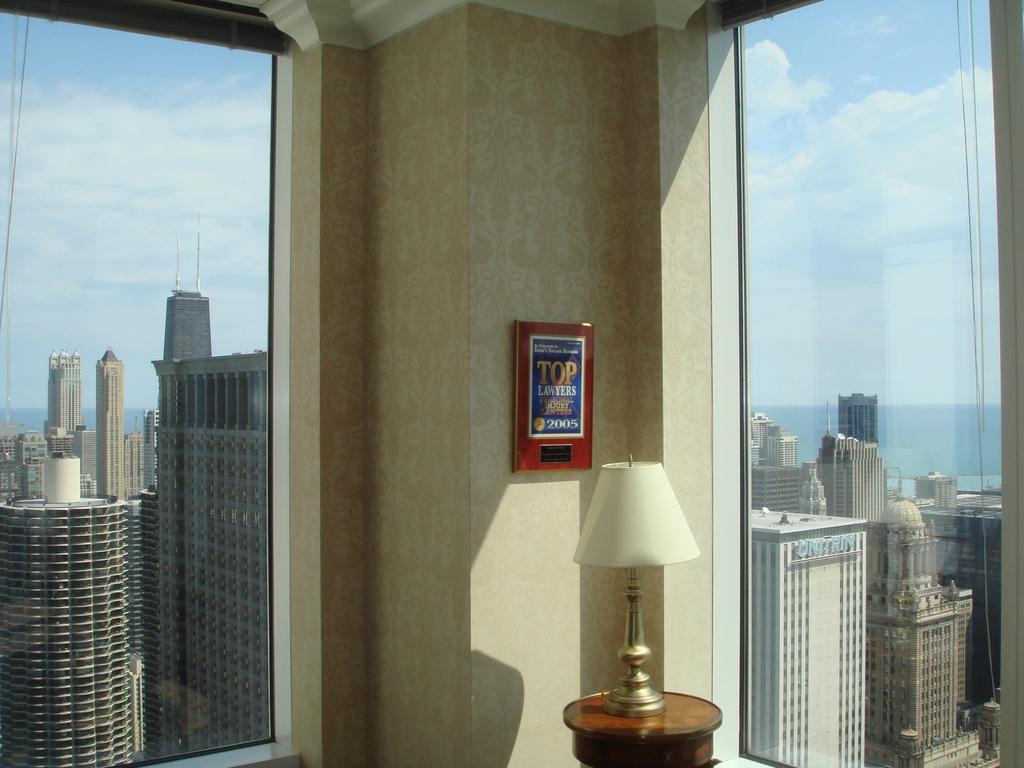In one or two sentences, can you explain what this image depicts? In this image, we can see some buildings. There is a board on the wall. There is a lamp on the stool which is at the bottom of the image. In the background of the image, there is a sky. 